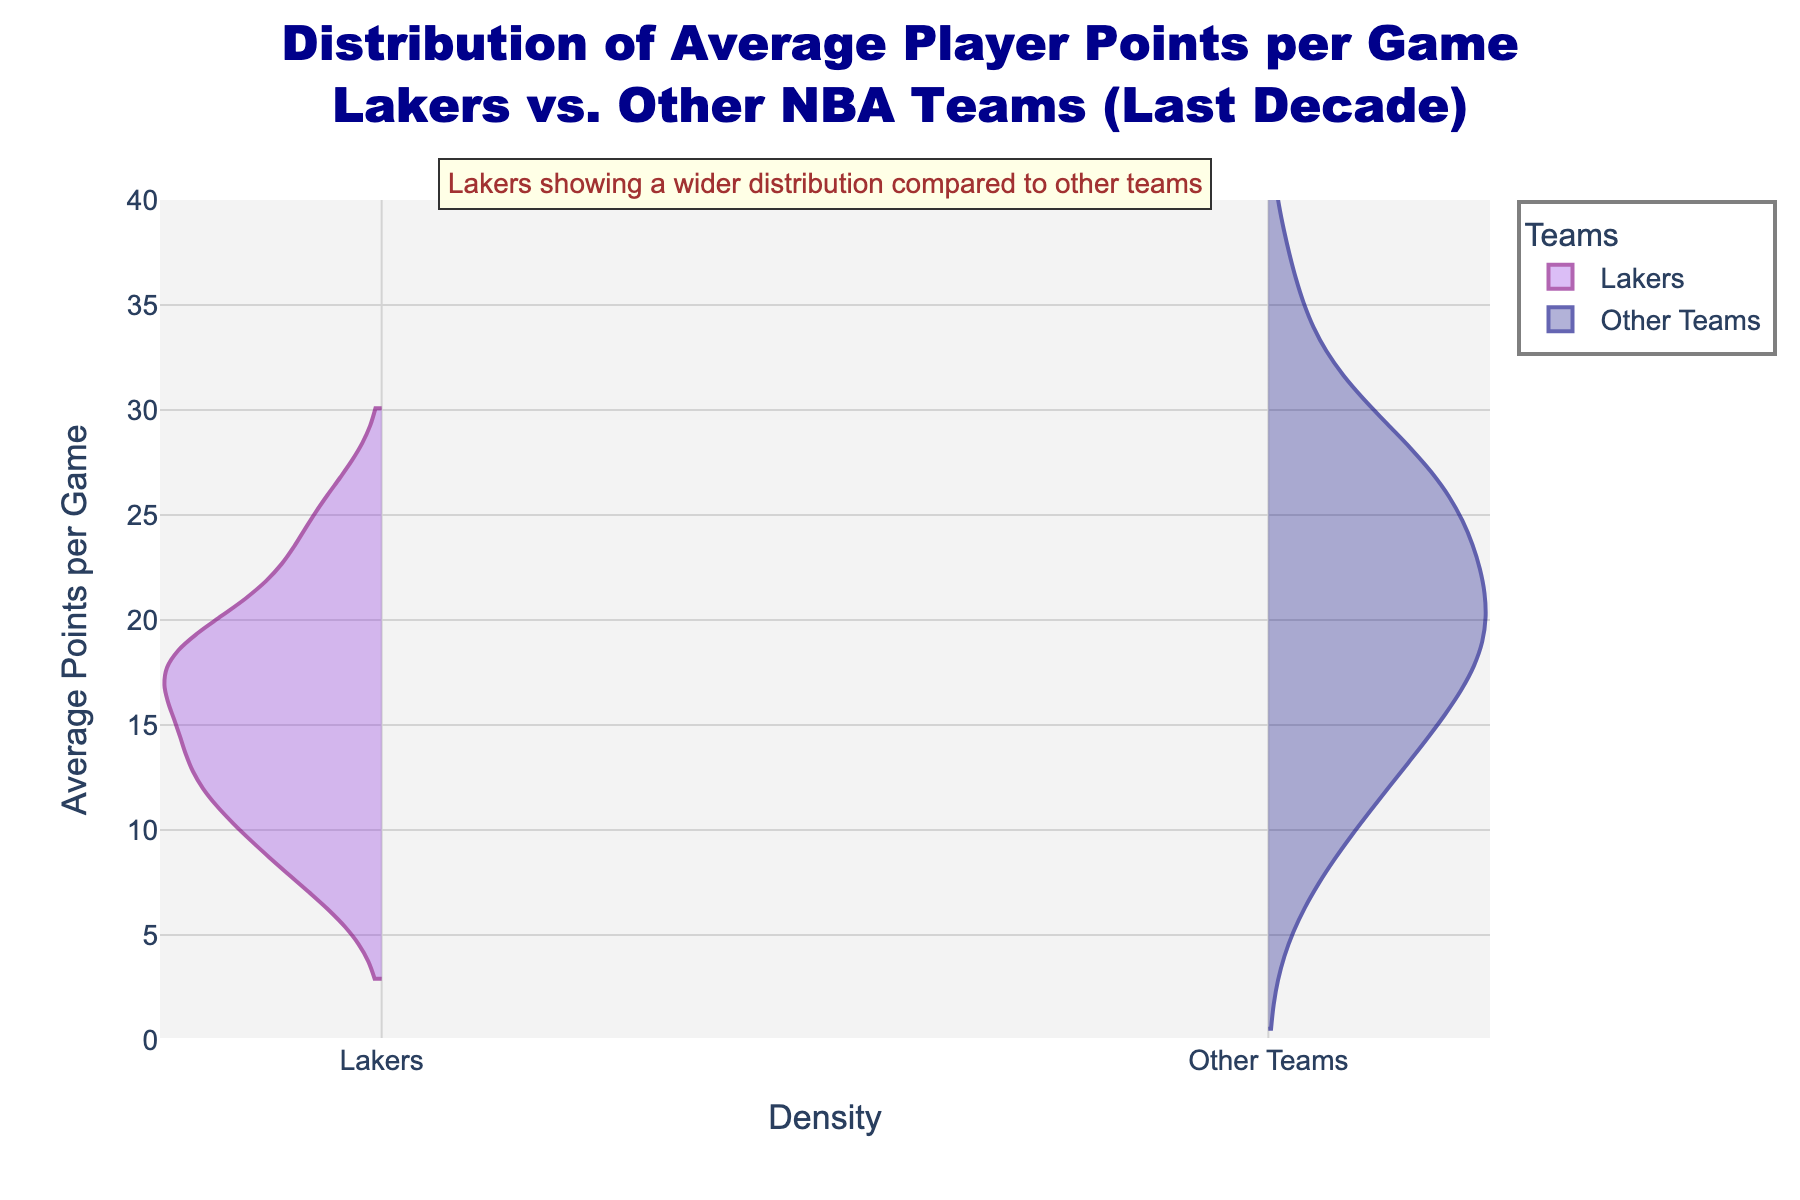What's the title of the figure? The title is displayed prominently at the top of the figure.
Answer: Distribution of Average Player Points per Game: Lakers vs. Other NBA Teams (Last Decade) What are the colors used to represent the Lakers and Other Teams? The colors are specified in the figure legend. The Lakers are purple with gold markers, and Other Teams are navy blue with silver markers.
Answer: Purple and navy blue How does the range of average points per game for Lakers players compare to that of players from other teams? By observing the y-axis, Lakers players' average points per game range from about 8 to 25, while Other Teams range from about 7 to 36.
Answer: Lakers: 8 to 25, Other Teams: 7 to 36 Which team shows a wider distribution of average points per game? Based on the annotation and the spread of the violin plots, the Lakers have a slightly wider distribution compared to Other Teams.
Answer: Lakers What is the approximate median value of average points per game for Lakers players? The median value will be around the middle of the y-axis range for the Lakers violin plot.
Answer: Around 17 points per game What is the maximum average points per game observed for any player in the data? The maximum value observed on the y-axis for the Other Teams violin plot is around 36, which is James Harden's data point.
Answer: 36 points per game How does the density of Lakers' players averaging around 25 points per game compare to Other Teams? The density can be understood by the width of the violin plot at 25 points. The Lakers' plot is narrower at 25 points compared to Other Teams', indicating fewer Lakers players at that average.
Answer: Lower density for Lakers What can we infer about the most frequent scoring range for the Lakers compared to Other Teams? The widest part of the violin plot indicates the most frequent values. For Lakers, the widest part is between 15-20 points, while for Other Teams, it's more spread out but includes higher values.
Answer: Lakers: 15-20 points, Other Teams: Spread out How often do Lakers players score above 20 points per game compared to Other Teams? By comparing the width and density of both violin plots above the 20 points mark, Other Teams show more frequent occurrences.
Answer: Less frequent for Lakers 